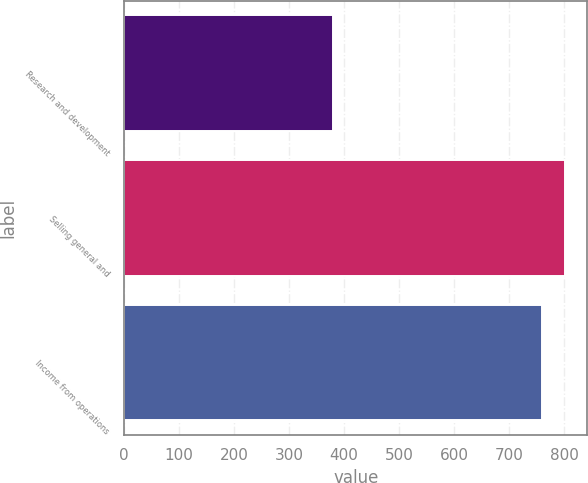Convert chart to OTSL. <chart><loc_0><loc_0><loc_500><loc_500><bar_chart><fcel>Research and development<fcel>Selling general and<fcel>Income from operations<nl><fcel>379<fcel>801.9<fcel>760<nl></chart> 